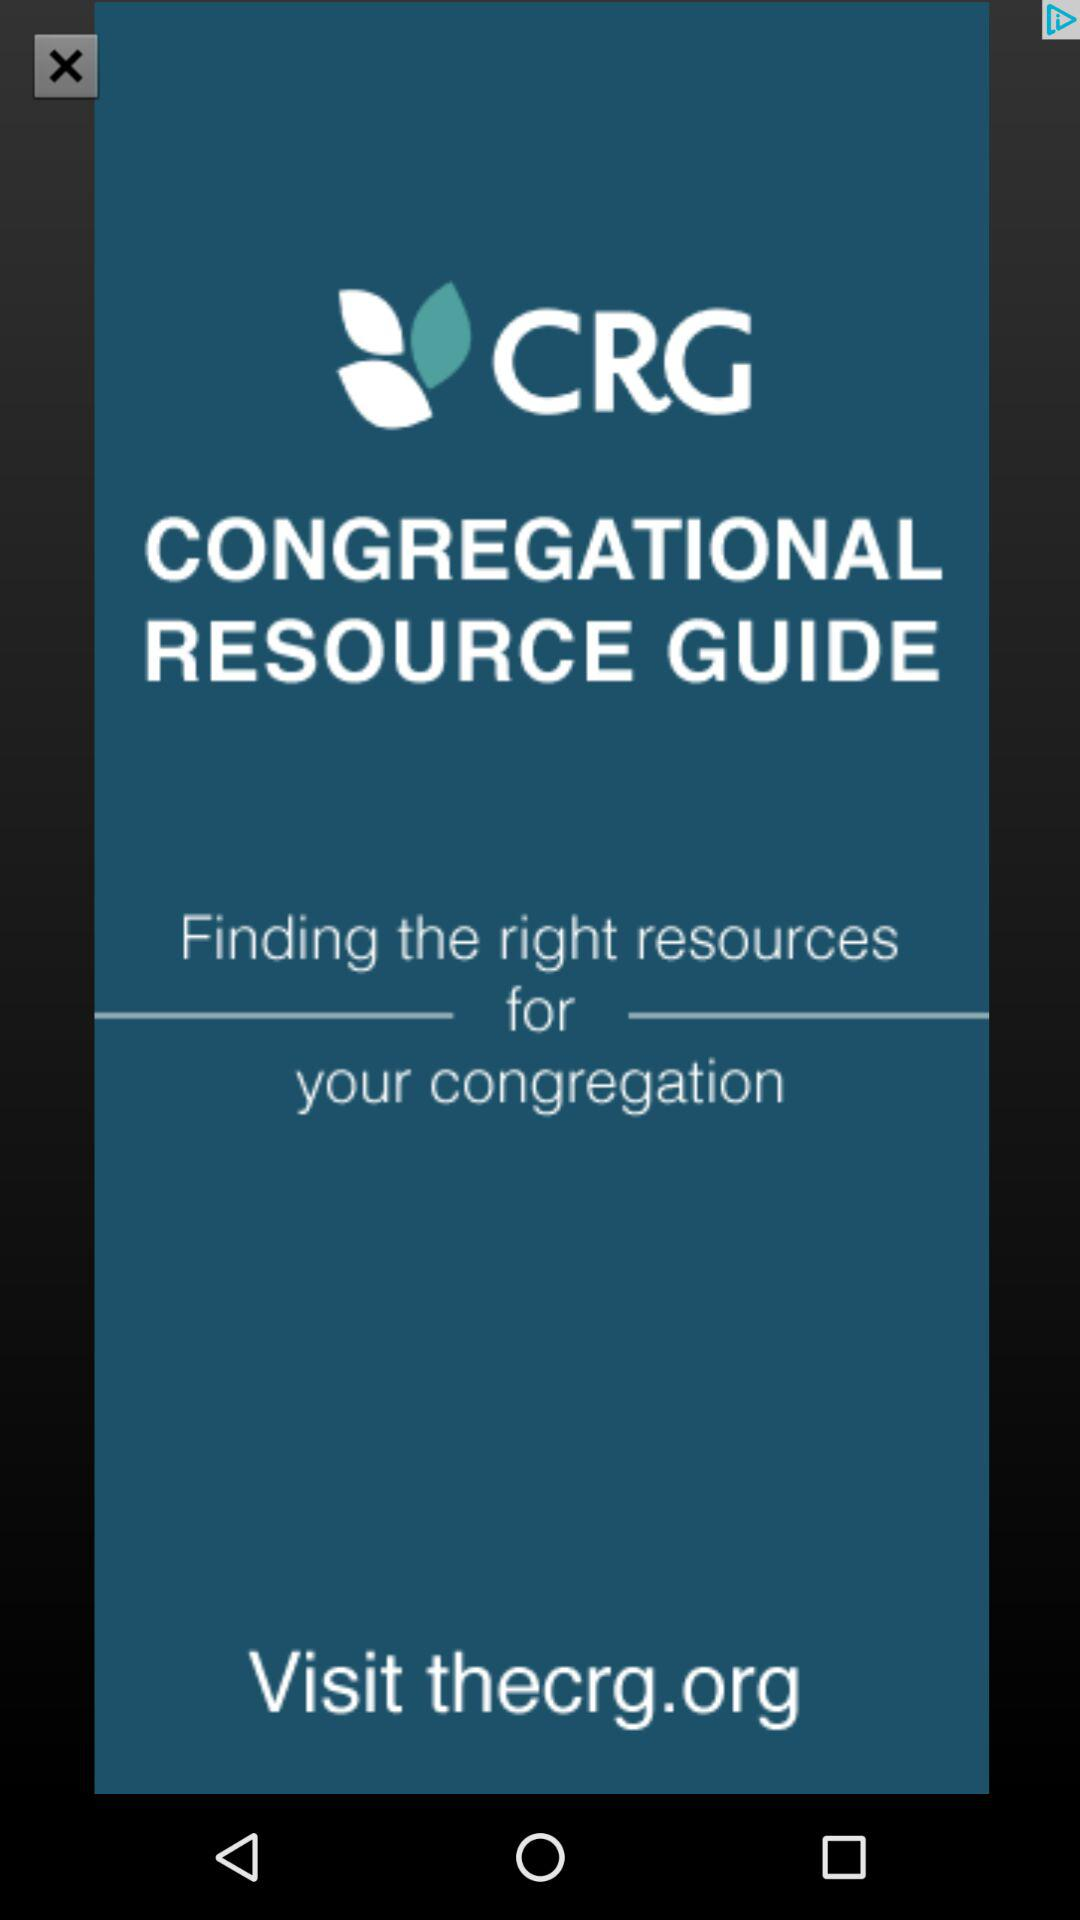What is the application name?
When the provided information is insufficient, respond with <no answer>. <no answer> 